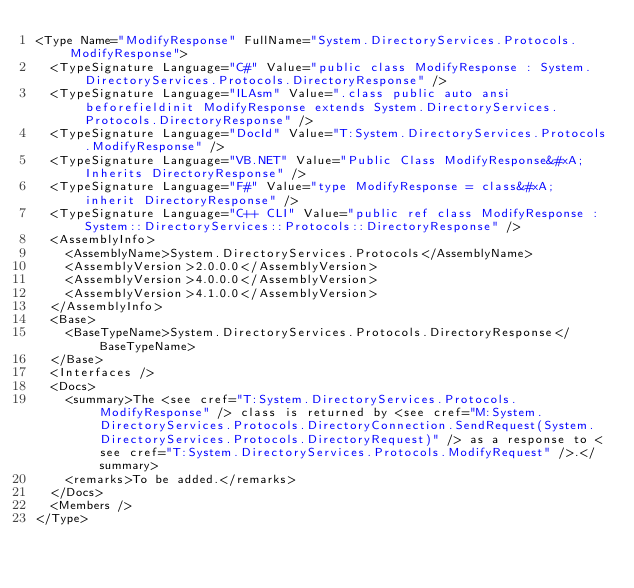<code> <loc_0><loc_0><loc_500><loc_500><_XML_><Type Name="ModifyResponse" FullName="System.DirectoryServices.Protocols.ModifyResponse">
  <TypeSignature Language="C#" Value="public class ModifyResponse : System.DirectoryServices.Protocols.DirectoryResponse" />
  <TypeSignature Language="ILAsm" Value=".class public auto ansi beforefieldinit ModifyResponse extends System.DirectoryServices.Protocols.DirectoryResponse" />
  <TypeSignature Language="DocId" Value="T:System.DirectoryServices.Protocols.ModifyResponse" />
  <TypeSignature Language="VB.NET" Value="Public Class ModifyResponse&#xA;Inherits DirectoryResponse" />
  <TypeSignature Language="F#" Value="type ModifyResponse = class&#xA;    inherit DirectoryResponse" />
  <TypeSignature Language="C++ CLI" Value="public ref class ModifyResponse : System::DirectoryServices::Protocols::DirectoryResponse" />
  <AssemblyInfo>
    <AssemblyName>System.DirectoryServices.Protocols</AssemblyName>
    <AssemblyVersion>2.0.0.0</AssemblyVersion>
    <AssemblyVersion>4.0.0.0</AssemblyVersion>
    <AssemblyVersion>4.1.0.0</AssemblyVersion>
  </AssemblyInfo>
  <Base>
    <BaseTypeName>System.DirectoryServices.Protocols.DirectoryResponse</BaseTypeName>
  </Base>
  <Interfaces />
  <Docs>
    <summary>The <see cref="T:System.DirectoryServices.Protocols.ModifyResponse" /> class is returned by <see cref="M:System.DirectoryServices.Protocols.DirectoryConnection.SendRequest(System.DirectoryServices.Protocols.DirectoryRequest)" /> as a response to <see cref="T:System.DirectoryServices.Protocols.ModifyRequest" />.</summary>
    <remarks>To be added.</remarks>
  </Docs>
  <Members />
</Type>
</code> 